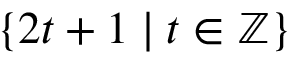Convert formula to latex. <formula><loc_0><loc_0><loc_500><loc_500>\{ 2 t + 1 | t \in \mathbb { Z } \}</formula> 